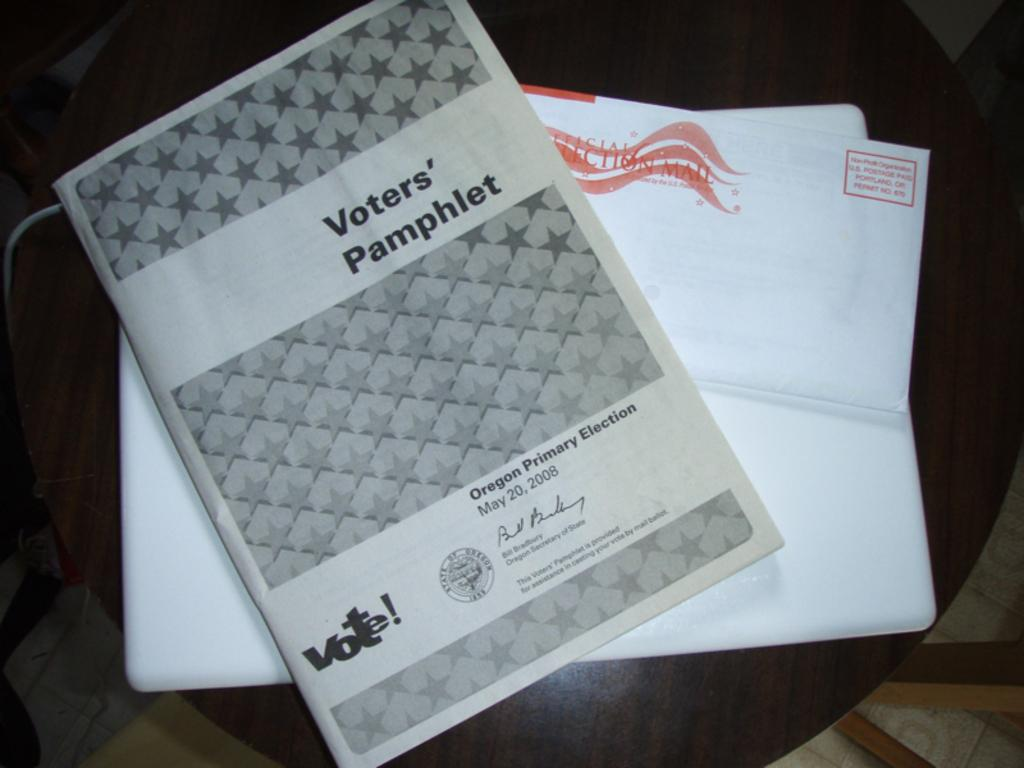What type of furniture is in the image? There is a chair in the image. What is placed on the chair? There is a paper and a book on the chair. What materials can be seen in the background of the image? Wooden sticks and a wire are visible in the background of the image. Is there a carpenter working on a bed in the image? There is no carpenter or bed present in the image. 